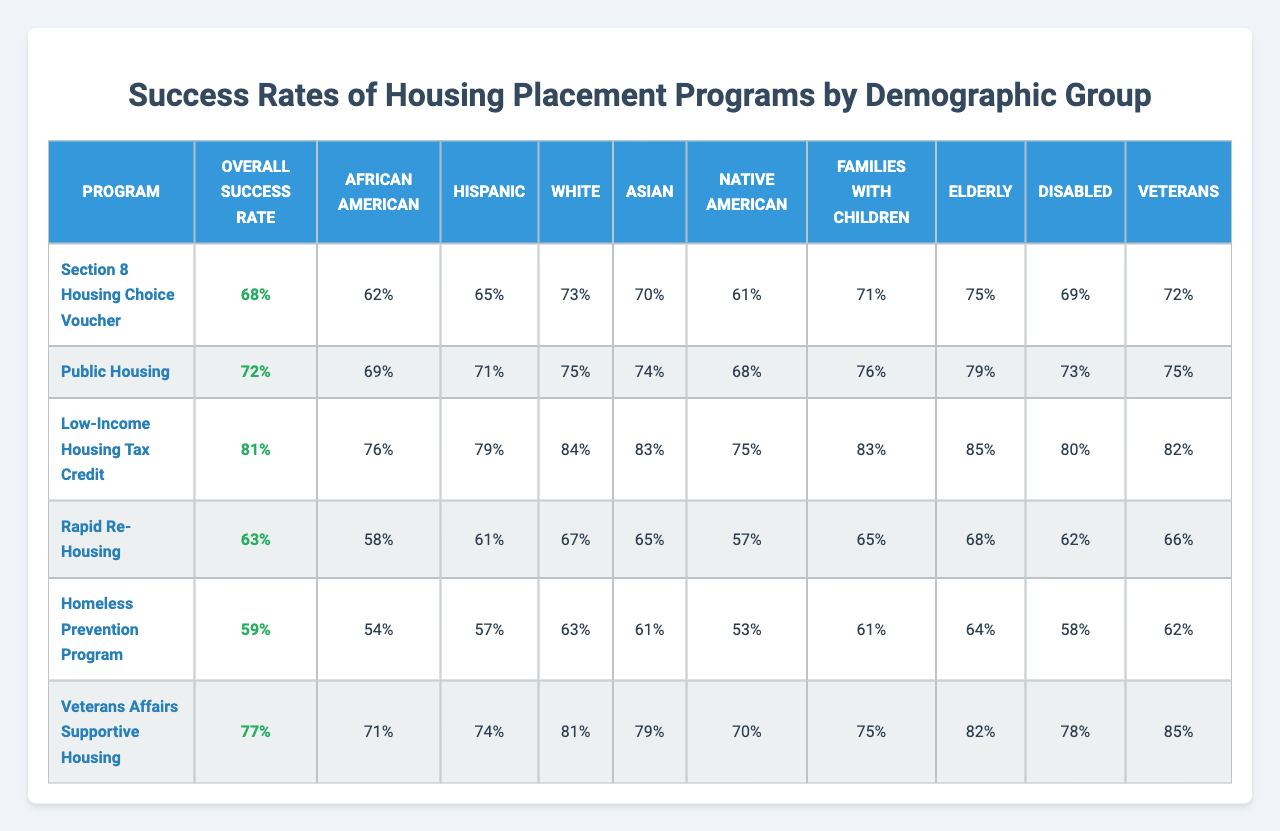What is the overall success rate of the Rapid Re-Housing program? The overall success rate of the Rapid Re-Housing program can be found in the second column of the table, which shows an overall success rate of 63%.
Answer: 63% Which demographic group has the highest success rate in the Low-Income Housing Tax Credit program? Looking at the Low-Income Housing Tax Credit program row, the highest success rate is found under the White demographic, which is 84%.
Answer: White What is the success rate for Elderly individuals in the Public Housing program? The success rate for Elderly individuals is listed in the Public Housing row under the Elderly column, which shows a success rate of 79%.
Answer: 79% Is the success rate for Hispanic individuals in the Section 8 Housing Choice Voucher program greater than the overall success rate for that program? The success rate for Hispanic individuals in the Section 8 program is 65%, which is lower than the overall success rate of 68%. Therefore, the answer is no.
Answer: No What is the difference between the success rates of Disabled and Veterans in the Homeless Prevention Program? The success rate for Disabled individuals in the Homeless Prevention Program is 58%, and for Veterans, it is 62%. The difference is calculated as 62% - 58% = 4%.
Answer: 4% Calculate the average success rate for Families with Children across all programs. To find the average, we add the success rates for Families with Children across all programs: (71% + 76% + 83% + 65% + 61% + 75%) = 431%. Dividing by the number of programs (6), we get 431% / 6 = 71.83%.
Answer: 71.83% Which demographic group has the lowest success rate in the Rapid Re-Housing program? In the Rapid Re-Housing program, the success rate for African American individuals is 58%, which is the lowest compared to other groups listed for this program.
Answer: African American What is the success rate for Native American individuals across all programs? To determine the success rate for Native American individuals across all programs, we look at the individual rates: 61%, 68%, 75%, 57%, 53%, and 70%. The overall average can be calculated as (61 + 68 + 75 + 57 + 53 + 70) / 6 = 66%.
Answer: 66% Did the Elderly group have a higher success rate in the Low-Income Housing Tax Credit program than the overall success rate for that program? The Elderly group has a success rate of 85% in the Low-Income Housing Tax Credit program, which is higher than the overall success rate of 81%. Therefore, the answer is yes.
Answer: Yes What is the overall average success rate across all housing placement programs? The overall average is calculated by summing the overall success rates: (68% + 72% + 81% + 63% + 59% + 77%) = 420%. Dividing by 6 gives us 420% / 6 = 70%.
Answer: 70% 